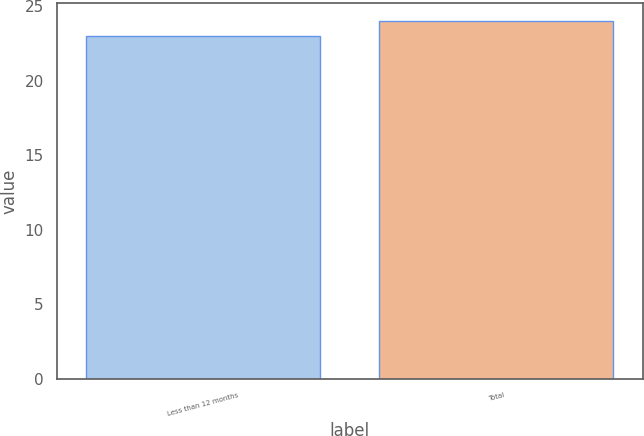<chart> <loc_0><loc_0><loc_500><loc_500><bar_chart><fcel>Less than 12 months<fcel>Total<nl><fcel>23<fcel>24<nl></chart> 